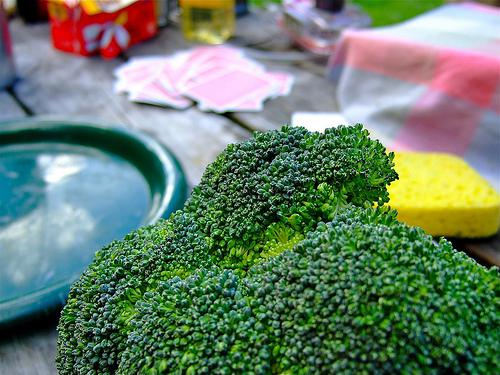Question: how is the photo?
Choices:
A. Fuzzy.
B. Sepia.
C. Ripped.
D. Clear.
Answer with the letter. Answer: D Question: what is it for?
Choices:
A. Drinking.
B. Cleaning with.
C. Tossing.
D. Eating.
Answer with the letter. Answer: D Question: who is present?
Choices:
A. A clown.
B. A dog.
C. A street vendor.
D. Nobody.
Answer with the letter. Answer: D 